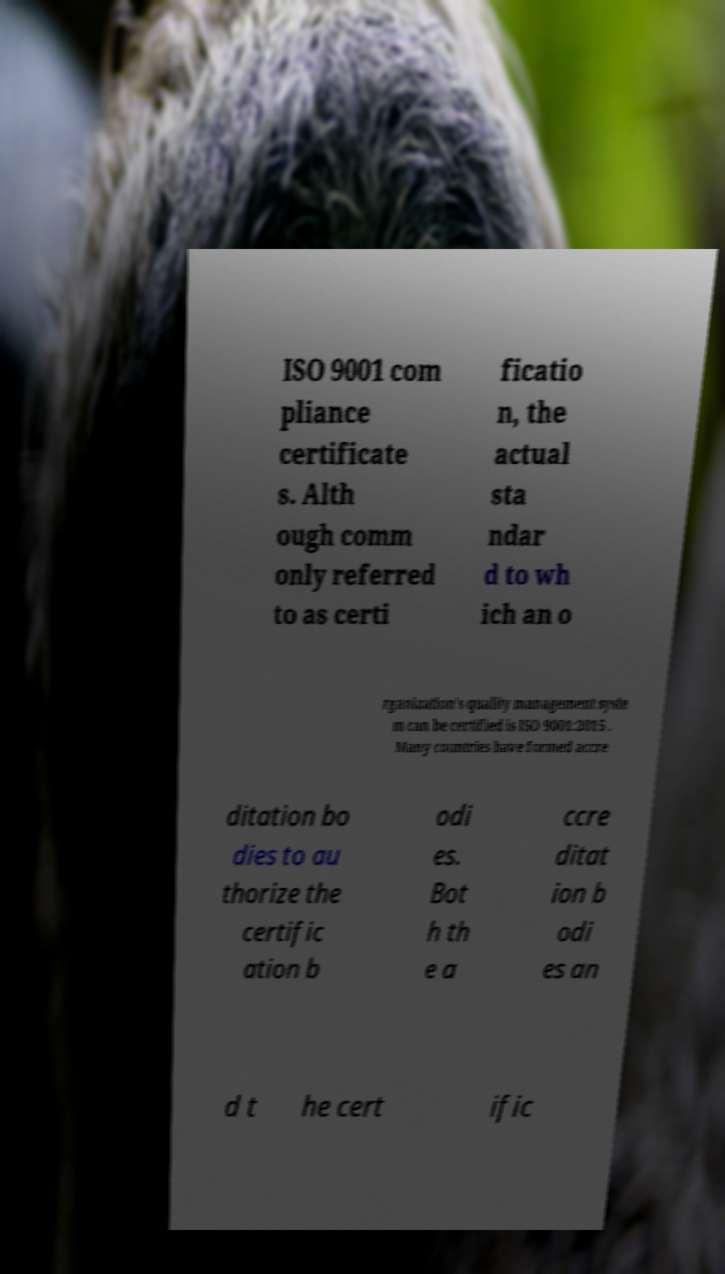Please read and relay the text visible in this image. What does it say? ISO 9001 com pliance certificate s. Alth ough comm only referred to as certi ficatio n, the actual sta ndar d to wh ich an o rganization's quality management syste m can be certified is ISO 9001:2015 . Many countries have formed accre ditation bo dies to au thorize the certific ation b odi es. Bot h th e a ccre ditat ion b odi es an d t he cert ific 